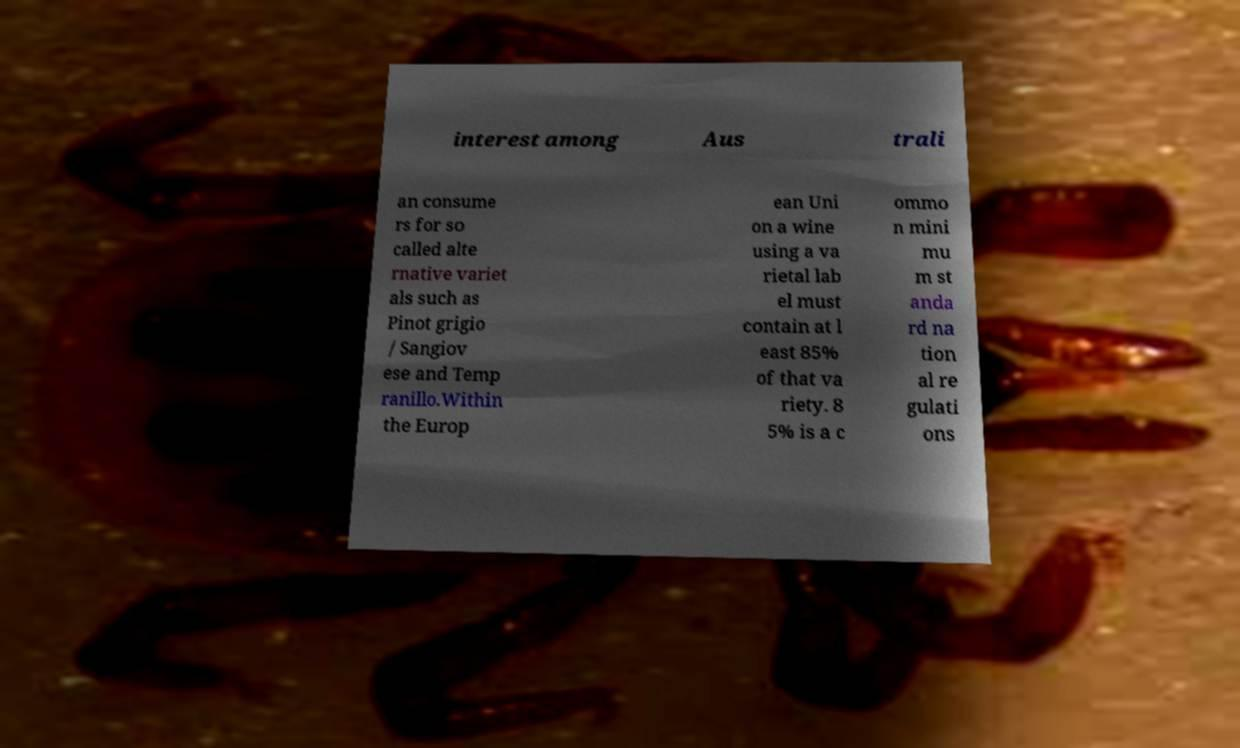I need the written content from this picture converted into text. Can you do that? interest among Aus trali an consume rs for so called alte rnative variet als such as Pinot grigio / Sangiov ese and Temp ranillo.Within the Europ ean Uni on a wine using a va rietal lab el must contain at l east 85% of that va riety. 8 5% is a c ommo n mini mu m st anda rd na tion al re gulati ons 